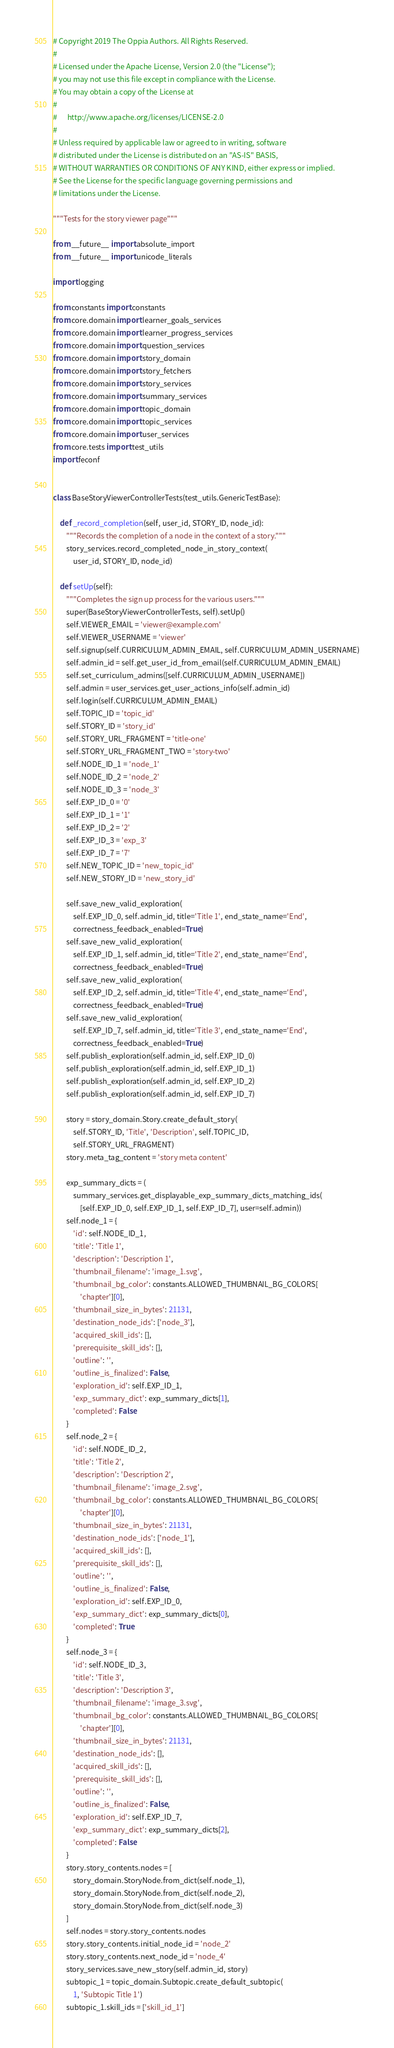<code> <loc_0><loc_0><loc_500><loc_500><_Python_># Copyright 2019 The Oppia Authors. All Rights Reserved.
#
# Licensed under the Apache License, Version 2.0 (the "License");
# you may not use this file except in compliance with the License.
# You may obtain a copy of the License at
#
#      http://www.apache.org/licenses/LICENSE-2.0
#
# Unless required by applicable law or agreed to in writing, software
# distributed under the License is distributed on an "AS-IS" BASIS,
# WITHOUT WARRANTIES OR CONDITIONS OF ANY KIND, either express or implied.
# See the License for the specific language governing permissions and
# limitations under the License.

"""Tests for the story viewer page"""

from __future__ import absolute_import
from __future__ import unicode_literals

import logging

from constants import constants
from core.domain import learner_goals_services
from core.domain import learner_progress_services
from core.domain import question_services
from core.domain import story_domain
from core.domain import story_fetchers
from core.domain import story_services
from core.domain import summary_services
from core.domain import topic_domain
from core.domain import topic_services
from core.domain import user_services
from core.tests import test_utils
import feconf


class BaseStoryViewerControllerTests(test_utils.GenericTestBase):

    def _record_completion(self, user_id, STORY_ID, node_id):
        """Records the completion of a node in the context of a story."""
        story_services.record_completed_node_in_story_context(
            user_id, STORY_ID, node_id)

    def setUp(self):
        """Completes the sign up process for the various users."""
        super(BaseStoryViewerControllerTests, self).setUp()
        self.VIEWER_EMAIL = 'viewer@example.com'
        self.VIEWER_USERNAME = 'viewer'
        self.signup(self.CURRICULUM_ADMIN_EMAIL, self.CURRICULUM_ADMIN_USERNAME)
        self.admin_id = self.get_user_id_from_email(self.CURRICULUM_ADMIN_EMAIL)
        self.set_curriculum_admins([self.CURRICULUM_ADMIN_USERNAME])
        self.admin = user_services.get_user_actions_info(self.admin_id)
        self.login(self.CURRICULUM_ADMIN_EMAIL)
        self.TOPIC_ID = 'topic_id'
        self.STORY_ID = 'story_id'
        self.STORY_URL_FRAGMENT = 'title-one'
        self.STORY_URL_FRAGMENT_TWO = 'story-two'
        self.NODE_ID_1 = 'node_1'
        self.NODE_ID_2 = 'node_2'
        self.NODE_ID_3 = 'node_3'
        self.EXP_ID_0 = '0'
        self.EXP_ID_1 = '1'
        self.EXP_ID_2 = '2'
        self.EXP_ID_3 = 'exp_3'
        self.EXP_ID_7 = '7'
        self.NEW_TOPIC_ID = 'new_topic_id'
        self.NEW_STORY_ID = 'new_story_id'

        self.save_new_valid_exploration(
            self.EXP_ID_0, self.admin_id, title='Title 1', end_state_name='End',
            correctness_feedback_enabled=True)
        self.save_new_valid_exploration(
            self.EXP_ID_1, self.admin_id, title='Title 2', end_state_name='End',
            correctness_feedback_enabled=True)
        self.save_new_valid_exploration(
            self.EXP_ID_2, self.admin_id, title='Title 4', end_state_name='End',
            correctness_feedback_enabled=True)
        self.save_new_valid_exploration(
            self.EXP_ID_7, self.admin_id, title='Title 3', end_state_name='End',
            correctness_feedback_enabled=True)
        self.publish_exploration(self.admin_id, self.EXP_ID_0)
        self.publish_exploration(self.admin_id, self.EXP_ID_1)
        self.publish_exploration(self.admin_id, self.EXP_ID_2)
        self.publish_exploration(self.admin_id, self.EXP_ID_7)

        story = story_domain.Story.create_default_story(
            self.STORY_ID, 'Title', 'Description', self.TOPIC_ID,
            self.STORY_URL_FRAGMENT)
        story.meta_tag_content = 'story meta content'

        exp_summary_dicts = (
            summary_services.get_displayable_exp_summary_dicts_matching_ids(
                [self.EXP_ID_0, self.EXP_ID_1, self.EXP_ID_7], user=self.admin))
        self.node_1 = {
            'id': self.NODE_ID_1,
            'title': 'Title 1',
            'description': 'Description 1',
            'thumbnail_filename': 'image_1.svg',
            'thumbnail_bg_color': constants.ALLOWED_THUMBNAIL_BG_COLORS[
                'chapter'][0],
            'thumbnail_size_in_bytes': 21131,
            'destination_node_ids': ['node_3'],
            'acquired_skill_ids': [],
            'prerequisite_skill_ids': [],
            'outline': '',
            'outline_is_finalized': False,
            'exploration_id': self.EXP_ID_1,
            'exp_summary_dict': exp_summary_dicts[1],
            'completed': False
        }
        self.node_2 = {
            'id': self.NODE_ID_2,
            'title': 'Title 2',
            'description': 'Description 2',
            'thumbnail_filename': 'image_2.svg',
            'thumbnail_bg_color': constants.ALLOWED_THUMBNAIL_BG_COLORS[
                'chapter'][0],
            'thumbnail_size_in_bytes': 21131,
            'destination_node_ids': ['node_1'],
            'acquired_skill_ids': [],
            'prerequisite_skill_ids': [],
            'outline': '',
            'outline_is_finalized': False,
            'exploration_id': self.EXP_ID_0,
            'exp_summary_dict': exp_summary_dicts[0],
            'completed': True
        }
        self.node_3 = {
            'id': self.NODE_ID_3,
            'title': 'Title 3',
            'description': 'Description 3',
            'thumbnail_filename': 'image_3.svg',
            'thumbnail_bg_color': constants.ALLOWED_THUMBNAIL_BG_COLORS[
                'chapter'][0],
            'thumbnail_size_in_bytes': 21131,
            'destination_node_ids': [],
            'acquired_skill_ids': [],
            'prerequisite_skill_ids': [],
            'outline': '',
            'outline_is_finalized': False,
            'exploration_id': self.EXP_ID_7,
            'exp_summary_dict': exp_summary_dicts[2],
            'completed': False
        }
        story.story_contents.nodes = [
            story_domain.StoryNode.from_dict(self.node_1),
            story_domain.StoryNode.from_dict(self.node_2),
            story_domain.StoryNode.from_dict(self.node_3)
        ]
        self.nodes = story.story_contents.nodes
        story.story_contents.initial_node_id = 'node_2'
        story.story_contents.next_node_id = 'node_4'
        story_services.save_new_story(self.admin_id, story)
        subtopic_1 = topic_domain.Subtopic.create_default_subtopic(
            1, 'Subtopic Title 1')
        subtopic_1.skill_ids = ['skill_id_1']</code> 